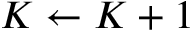<formula> <loc_0><loc_0><loc_500><loc_500>K \gets K + 1</formula> 